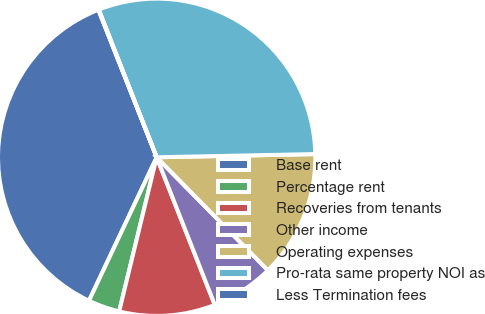Convert chart. <chart><loc_0><loc_0><loc_500><loc_500><pie_chart><fcel>Base rent<fcel>Percentage rent<fcel>Recoveries from tenants<fcel>Other income<fcel>Operating expenses<fcel>Pro-rata same property NOI as<fcel>Less Termination fees<nl><fcel>36.99%<fcel>3.22%<fcel>9.77%<fcel>6.4%<fcel>12.95%<fcel>30.63%<fcel>0.04%<nl></chart> 